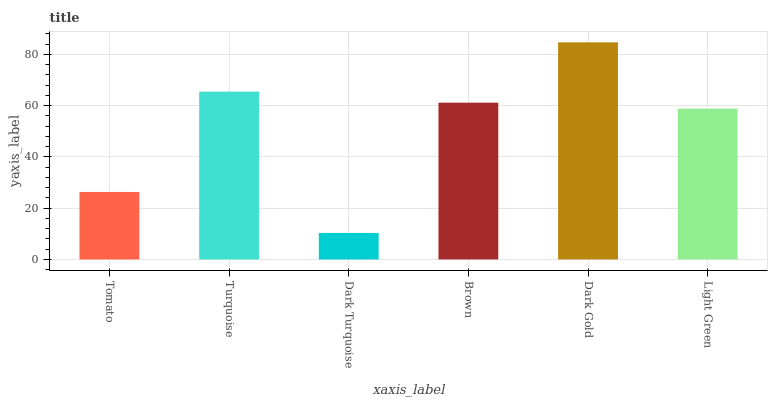Is Dark Turquoise the minimum?
Answer yes or no. Yes. Is Dark Gold the maximum?
Answer yes or no. Yes. Is Turquoise the minimum?
Answer yes or no. No. Is Turquoise the maximum?
Answer yes or no. No. Is Turquoise greater than Tomato?
Answer yes or no. Yes. Is Tomato less than Turquoise?
Answer yes or no. Yes. Is Tomato greater than Turquoise?
Answer yes or no. No. Is Turquoise less than Tomato?
Answer yes or no. No. Is Brown the high median?
Answer yes or no. Yes. Is Light Green the low median?
Answer yes or no. Yes. Is Light Green the high median?
Answer yes or no. No. Is Tomato the low median?
Answer yes or no. No. 